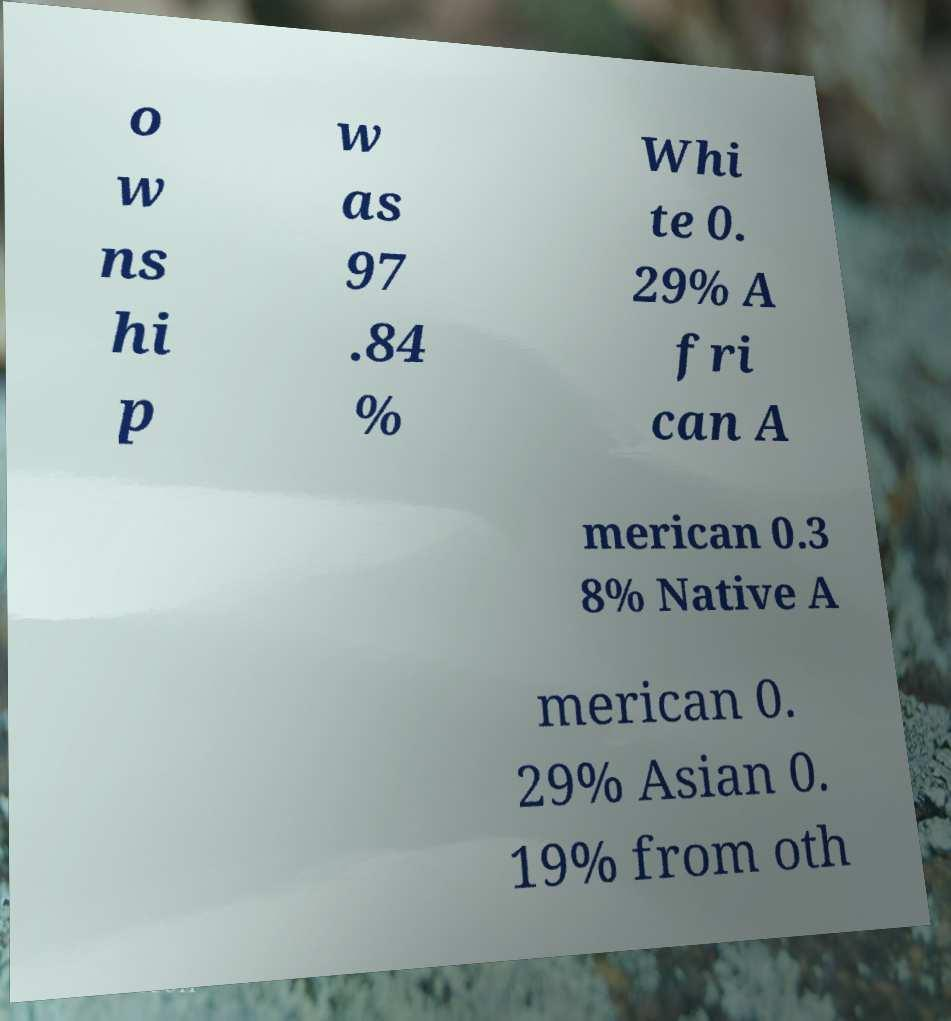There's text embedded in this image that I need extracted. Can you transcribe it verbatim? o w ns hi p w as 97 .84 % Whi te 0. 29% A fri can A merican 0.3 8% Native A merican 0. 29% Asian 0. 19% from oth 